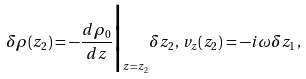Convert formula to latex. <formula><loc_0><loc_0><loc_500><loc_500>\delta \rho ( z _ { 2 } ) = - \frac { d \rho _ { 0 } } { d z } \Big | _ { z = z _ { 2 } } \delta z _ { 2 } , \, v _ { z } ( z _ { 2 } ) = - i \omega \delta z _ { 1 } ,</formula> 